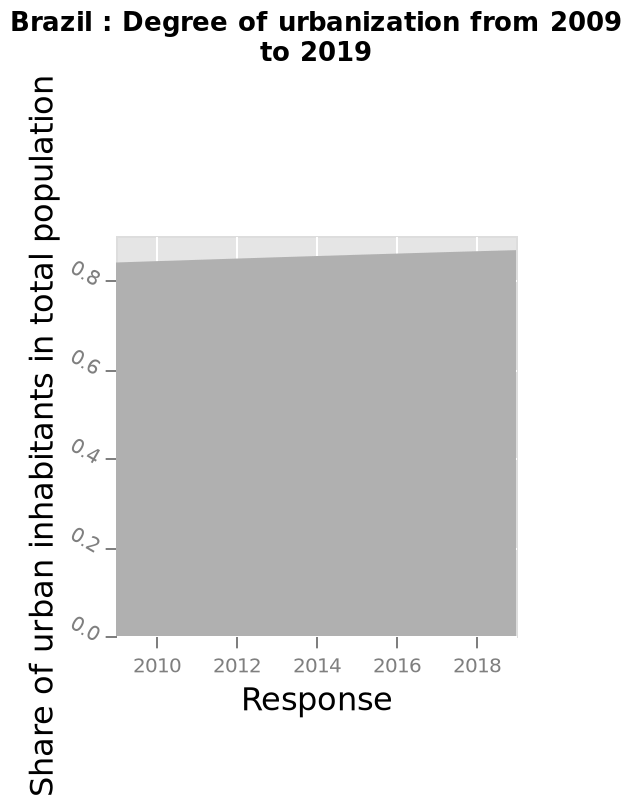<image>
please summary the statistics and relations of the chart The number of urban inhabitants has been steadily increasing through the measured timescale. How has the number of urban inhabitants been changing over time?  The number of urban inhabitants has been steadily increasing. 